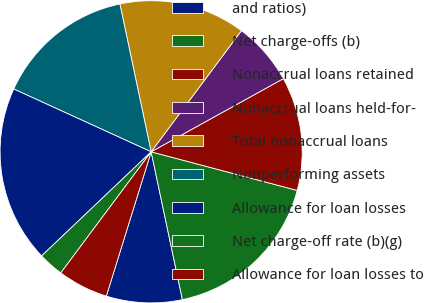<chart> <loc_0><loc_0><loc_500><loc_500><pie_chart><fcel>and ratios)<fcel>Net charge-offs (b)<fcel>Nonaccrual loans retained<fcel>Nonaccrual loans held-for-<fcel>Total nonaccrual loans<fcel>Nonperforming assets<fcel>Allowance for loan losses<fcel>Net charge-off rate (b)(g)<fcel>Allowance for loan losses to<nl><fcel>8.11%<fcel>17.57%<fcel>12.16%<fcel>6.76%<fcel>13.51%<fcel>14.86%<fcel>18.92%<fcel>2.7%<fcel>5.41%<nl></chart> 